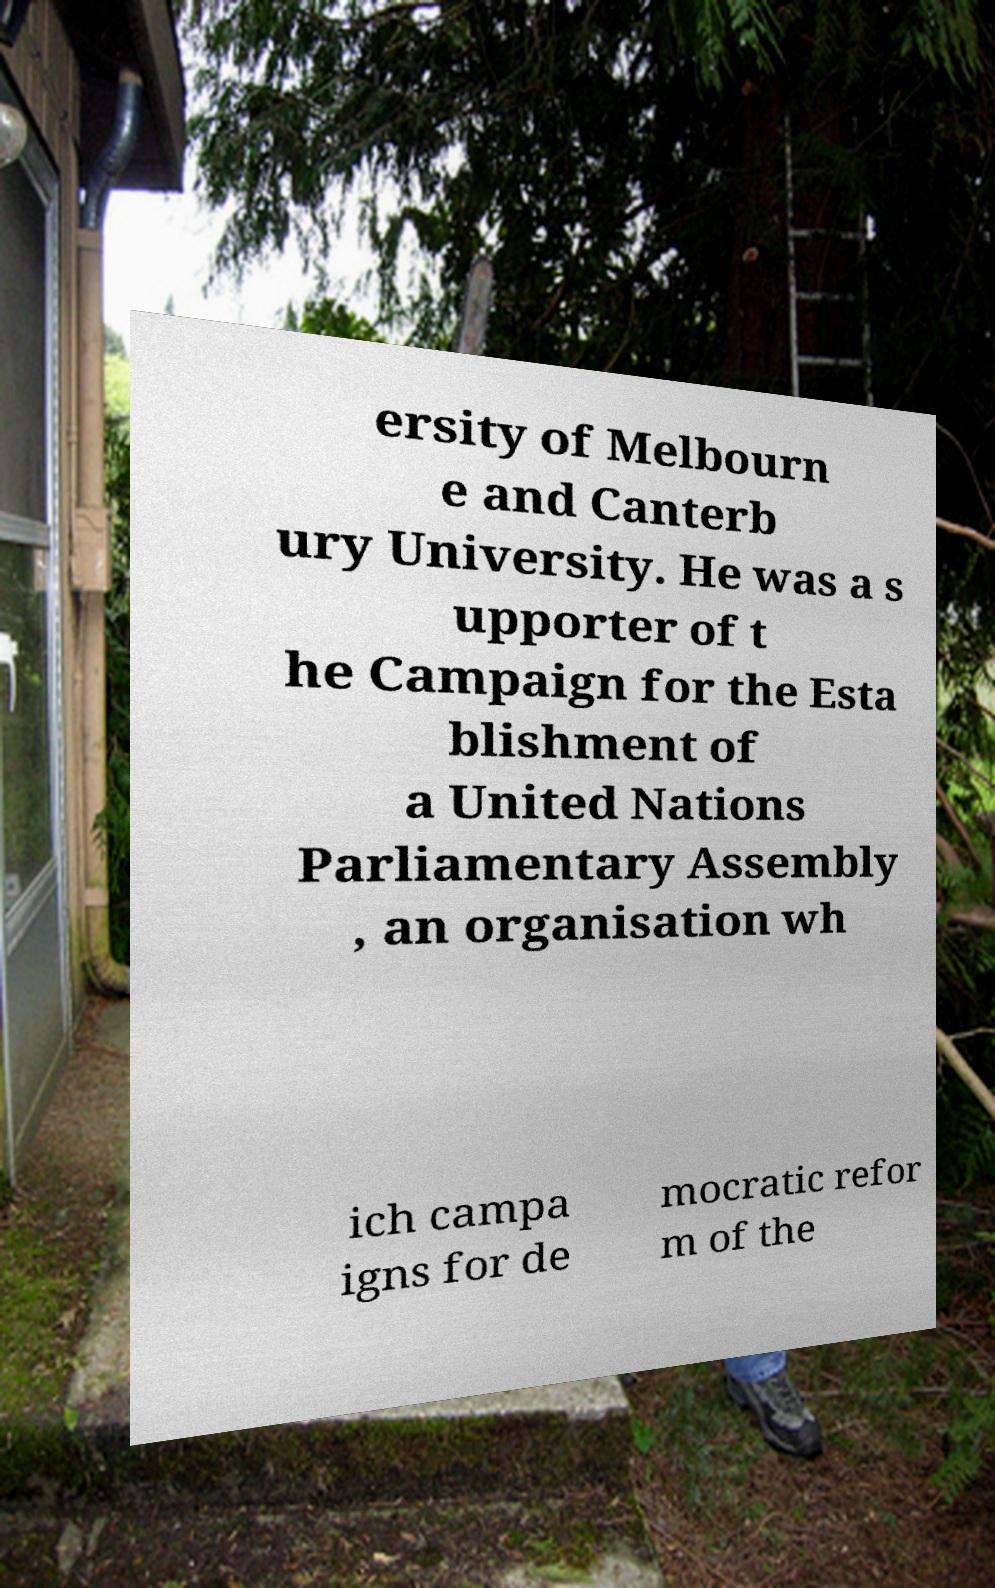For documentation purposes, I need the text within this image transcribed. Could you provide that? ersity of Melbourn e and Canterb ury University. He was a s upporter of t he Campaign for the Esta blishment of a United Nations Parliamentary Assembly , an organisation wh ich campa igns for de mocratic refor m of the 